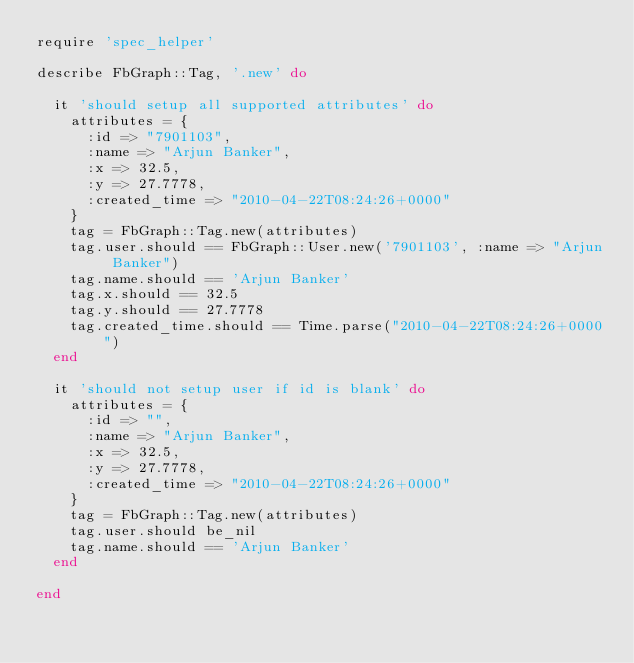Convert code to text. <code><loc_0><loc_0><loc_500><loc_500><_Ruby_>require 'spec_helper'

describe FbGraph::Tag, '.new' do

  it 'should setup all supported attributes' do
    attributes = {
      :id => "7901103",
      :name => "Arjun Banker",
      :x => 32.5,
      :y => 27.7778,
      :created_time => "2010-04-22T08:24:26+0000"
    }
    tag = FbGraph::Tag.new(attributes)
    tag.user.should == FbGraph::User.new('7901103', :name => "Arjun Banker")
    tag.name.should == 'Arjun Banker'
    tag.x.should == 32.5
    tag.y.should == 27.7778
    tag.created_time.should == Time.parse("2010-04-22T08:24:26+0000")
  end

  it 'should not setup user if id is blank' do
    attributes = {
      :id => "",
      :name => "Arjun Banker",
      :x => 32.5,
      :y => 27.7778,
      :created_time => "2010-04-22T08:24:26+0000"
    }
    tag = FbGraph::Tag.new(attributes)
    tag.user.should be_nil
    tag.name.should == 'Arjun Banker'
  end

end</code> 